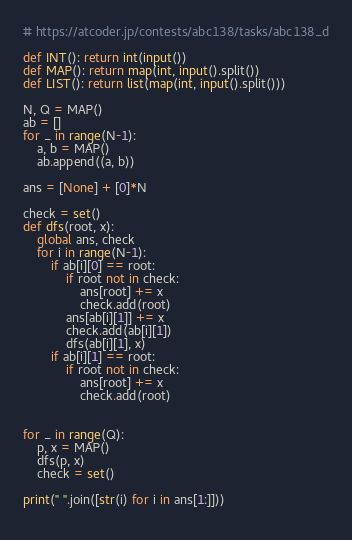Convert code to text. <code><loc_0><loc_0><loc_500><loc_500><_Python_># https://atcoder.jp/contests/abc138/tasks/abc138_d

def INT(): return int(input())
def MAP(): return map(int, input().split())
def LIST(): return list(map(int, input().split()))

N, Q = MAP()
ab = []
for _ in range(N-1):
    a, b = MAP()
    ab.append((a, b))

ans = [None] + [0]*N

check = set()
def dfs(root, x):
    global ans, check
    for i in range(N-1):
        if ab[i][0] == root:
            if root not in check:
                ans[root] += x
                check.add(root)
            ans[ab[i][1]] += x
            check.add(ab[i][1])
            dfs(ab[i][1], x)
        if ab[i][1] == root:
            if root not in check:
                ans[root] += x
                check.add(root)


for _ in range(Q):
    p, x = MAP()
    dfs(p, x)
    check = set()

print(" ".join([str(i) for i in ans[1:]]))
    

</code> 